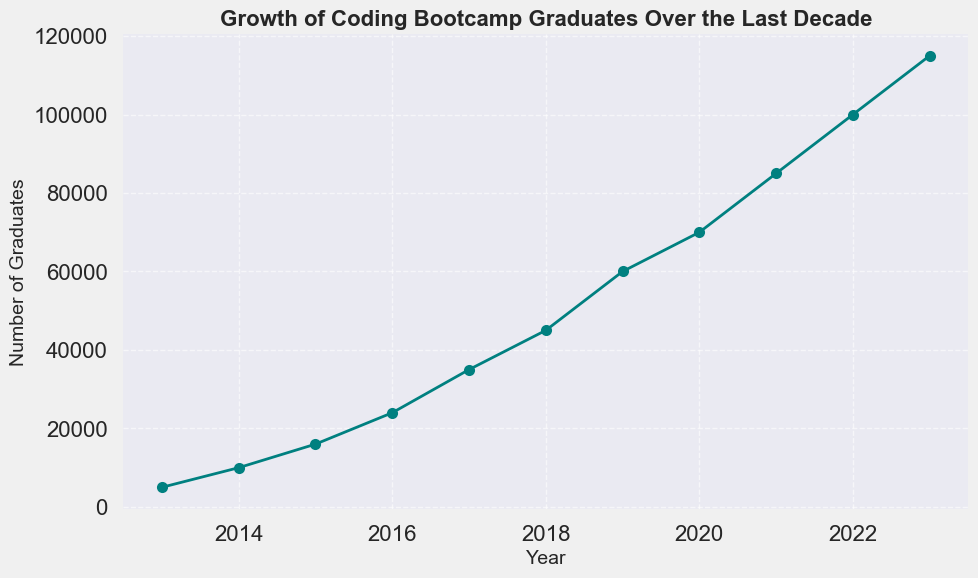What's the total number of graduates from 2013 to 2015? Find the sum of the number of graduates from 2013, 2014, and 2015. From the figure, the values are 5000 (2013), 10000 (2014), and 16000 (2015). The sum is 5000 + 10000 + 16000 = 31000.
Answer: 31000 In which year did the number of graduates first reach 60000? Identify the first year in the figure where the number of graduates equals 60000. This occurs in 2019.
Answer: 2019 Compare the number of graduates in 2016 to 2019. How much did it increase? Check the plot for the number of graduates in 2016 and 2019. In 2016, there were 24000 graduates and in 2019, there were 60000 graduates. The increase is 60000 - 24000 = 36000.
Answer: 36000 What is the percent increase in the number of graduates from 2020 to 2021? Calculate the percent increase using the formula ((new value - old value) / old value) * 100. For 2020 to 2021, the numbers are 70000 (2020) and 85000 (2021). The percent increase is ((85000 - 70000) / 70000) * 100 = 21.43%.
Answer: 21.43% What is the average number of graduates per year from 2013 to 2023? Find the average by summing the number of graduates for each year from 2013 to 2023, then dividing by the total number of years (11). The sum is 5000 + 10000 + 16000 + 24000 + 35000 + 45000 + 60000 + 70000 + 85000 + 100000 + 115000 = 584000. The average is 584000 / 11 ≈ 53091.
Answer: 53091 In which year did the number of graduates see the largest single-year increase? To determine the largest single-year increase, compare the difference from each year to the next. The largest increase is from 2021 to 2022, with an increase of 100000 - 85000 = 15000.
Answer: 2022 How does the number of graduates in 2023 compare to 2013? Compare the number of graduates in 2023 and 2013. In 2023 there are 115000 graduates and in 2013 there were 5000. The difference is 115000 - 5000 = 110000.
Answer: 110000 What is the median number of graduates from 2013 to 2023? To find the median, first, list the number of graduates in ascending order. The middle value in this dataset is the 6th value. The sorted values are 5000, 10000, 16000, 24000, 35000, 45000, 60000, 70000, 85000, 100000, 115000. The median is 45000.
Answer: 45000 Which year had the smallest number of graduates? Identify the year with the smallest number of graduates. From the figure, the smallest number of graduates is 5000 in 2013.
Answer: 2013 